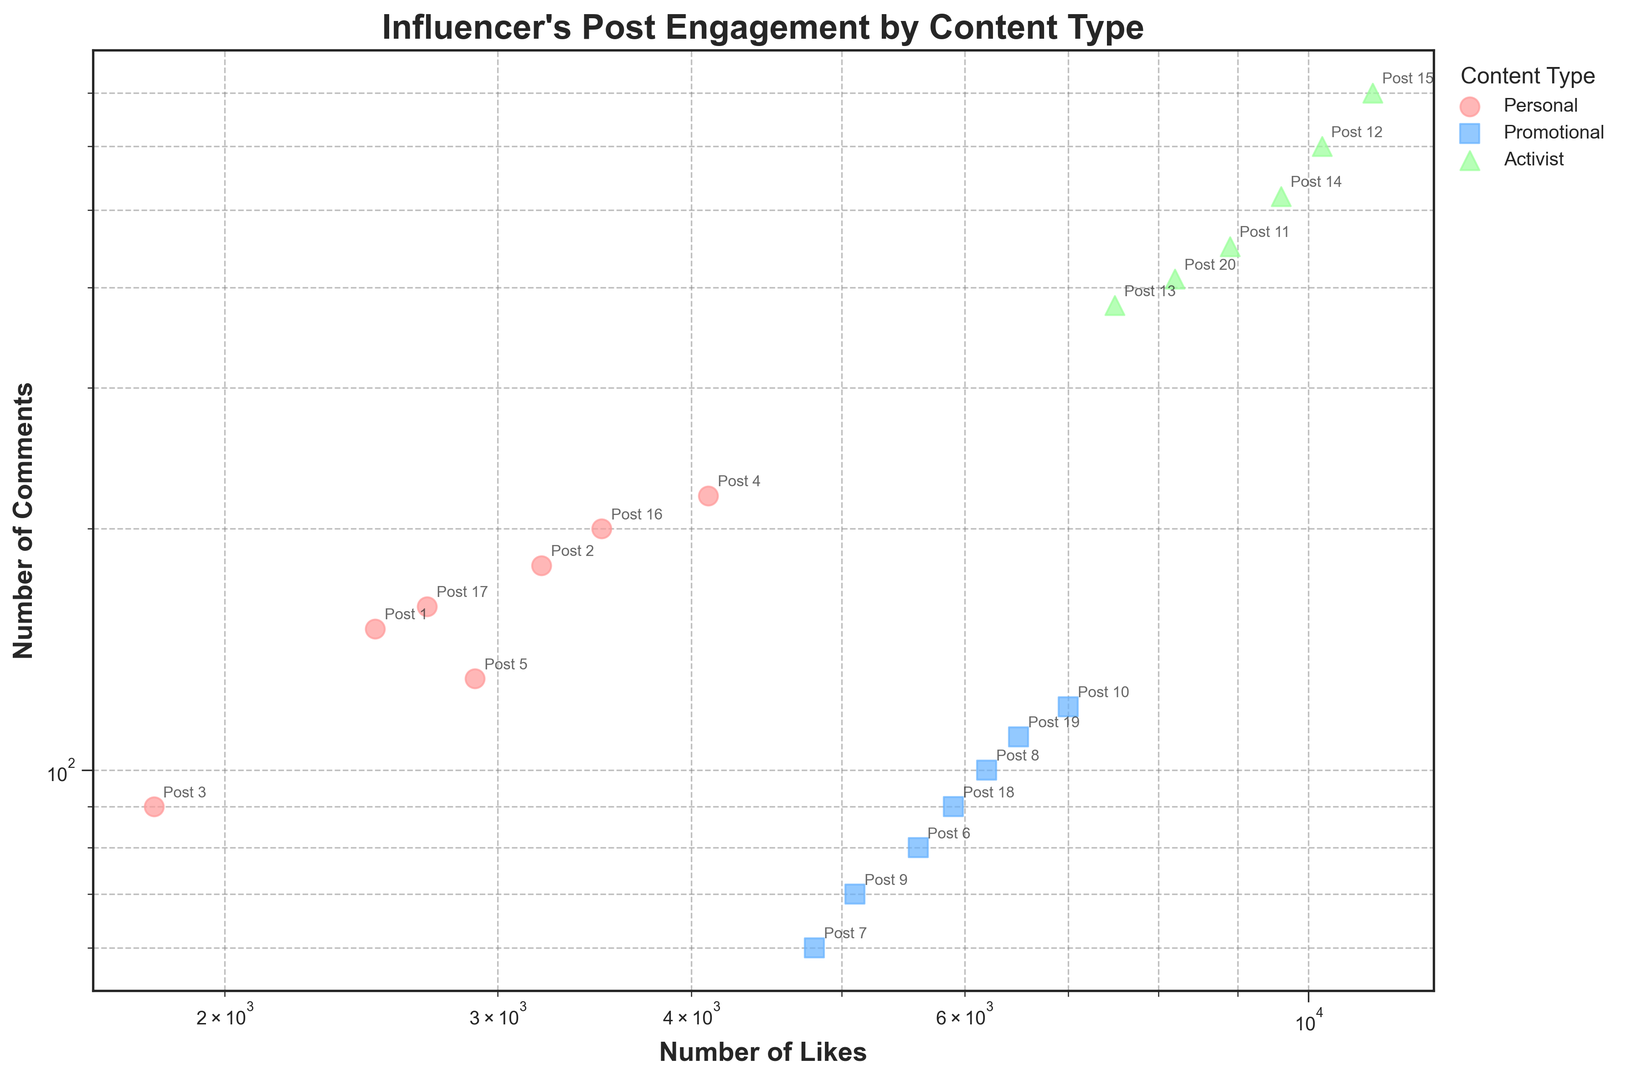Who has more likes on average, personal posts or promotional posts? Calculate the average number of likes for personal and promotional posts by summing each and dividing by the count of posts in each category. Personal posts: (2500 + 3200 + 1800 + 4100 + 2900 + 3500 + 2700) / 7 = 2957. Promotional posts: (5600 + 4800 + 6200 + 5100 + 7000 + 5900 + 6500) / 7 = 5871.57
Answer: Promotional posts Which content type has the highest number of comments on a post? Look at the comments for each post and identify the one with the highest number. Post 15 with content type activist has 700 comments, which is the highest.
Answer: Activist How much more (in percentage) comments do activist posts receive on average than personal posts? Calculate the average comments for each content type, then compute the percentage increase. Activist: (450 + 600 + 380 + 520 + 700 + 410) / 6 = 510. Personal: (150 + 180 + 90 + 220 + 130 + 200 + 160) / 7 = 161.43. Percentage increase: ((510 - 161.43) / 161.43) * 100 ≈ 215.93%
Answer: 215.93% What colored markers represent each content type in the plot? Identify the colors used for each content type as shown in the scatter plot legend.
Answer: Red for personal, blue for promotional, green for activist Do promotional posts consistently receive under 100 comments? Check each promotional post's number of comments to see if any exceed 100. Posts 8, 10, 19 all have more than 100 comments.
Answer: No Identify the post with the lowest engagement (sum of likes and comments) and its content type. Sum the likes and comments for all posts and identify the one with the lowest total. Post 3: 1800 + 90 = 1890 (personal content type)
Answer: Post 3 (Personal) Which post has the highest likes and what type of content is it? Look at the likes column and find the highest value. Post 15 with 11000 likes, content type activist.
Answer: Post 15 (Activist) What is the most common range of likes for personal posts? Evaluate the likes for personal posts and see if any set of values appear more frequently. Personal posts range from 1800-4100, with most clustering around 2500-3500
Answer: 2500-3500 Are there any posts where the number of comments exceeds the number of likes? Compare the likes and comments for each post to see if comments ever exceed likes. None of the posts have more comments than likes.
Answer: No 